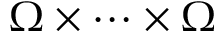<formula> <loc_0><loc_0><loc_500><loc_500>\Omega \times \dots \times \Omega</formula> 